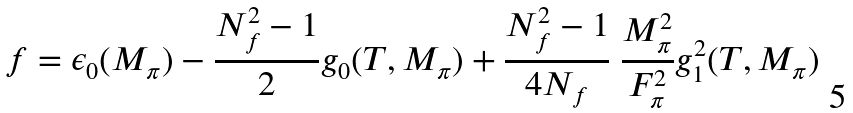<formula> <loc_0><loc_0><loc_500><loc_500>f = \epsilon _ { 0 } ( M _ { \pi } ) - \frac { N _ { f } ^ { 2 } - 1 } 2 g _ { 0 } ( T , M _ { \pi } ) + \frac { N _ { f } ^ { 2 } - 1 } { 4 N _ { f } } \ \frac { M _ { \pi } ^ { 2 } } { F _ { \pi } ^ { 2 } } g _ { 1 } ^ { 2 } ( T , M _ { \pi } )</formula> 